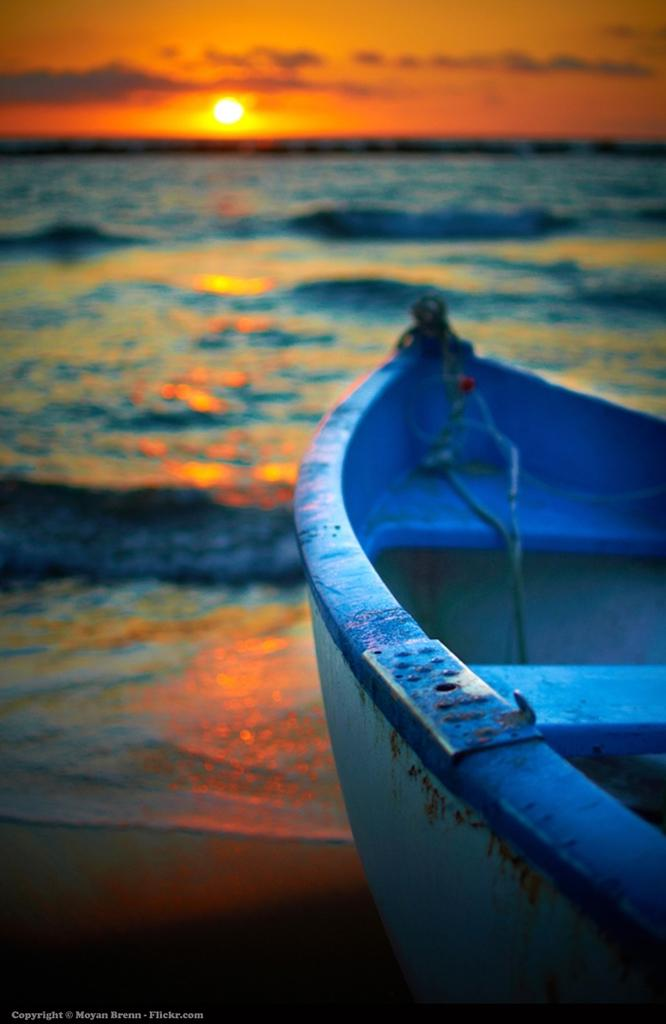What is the main subject of the image? The main subject of the image is a boat. Where is the boat located in the image? The boat is in front in the image. What is the primary setting of the image? The primary setting of the image is water. Can you describe the background of the image? The background of the image includes sky, and the sun is observable in the sky. What type of clock is hanging on the wall in the image? There is no clock present in the image; it features a boat in water with a sky background. 